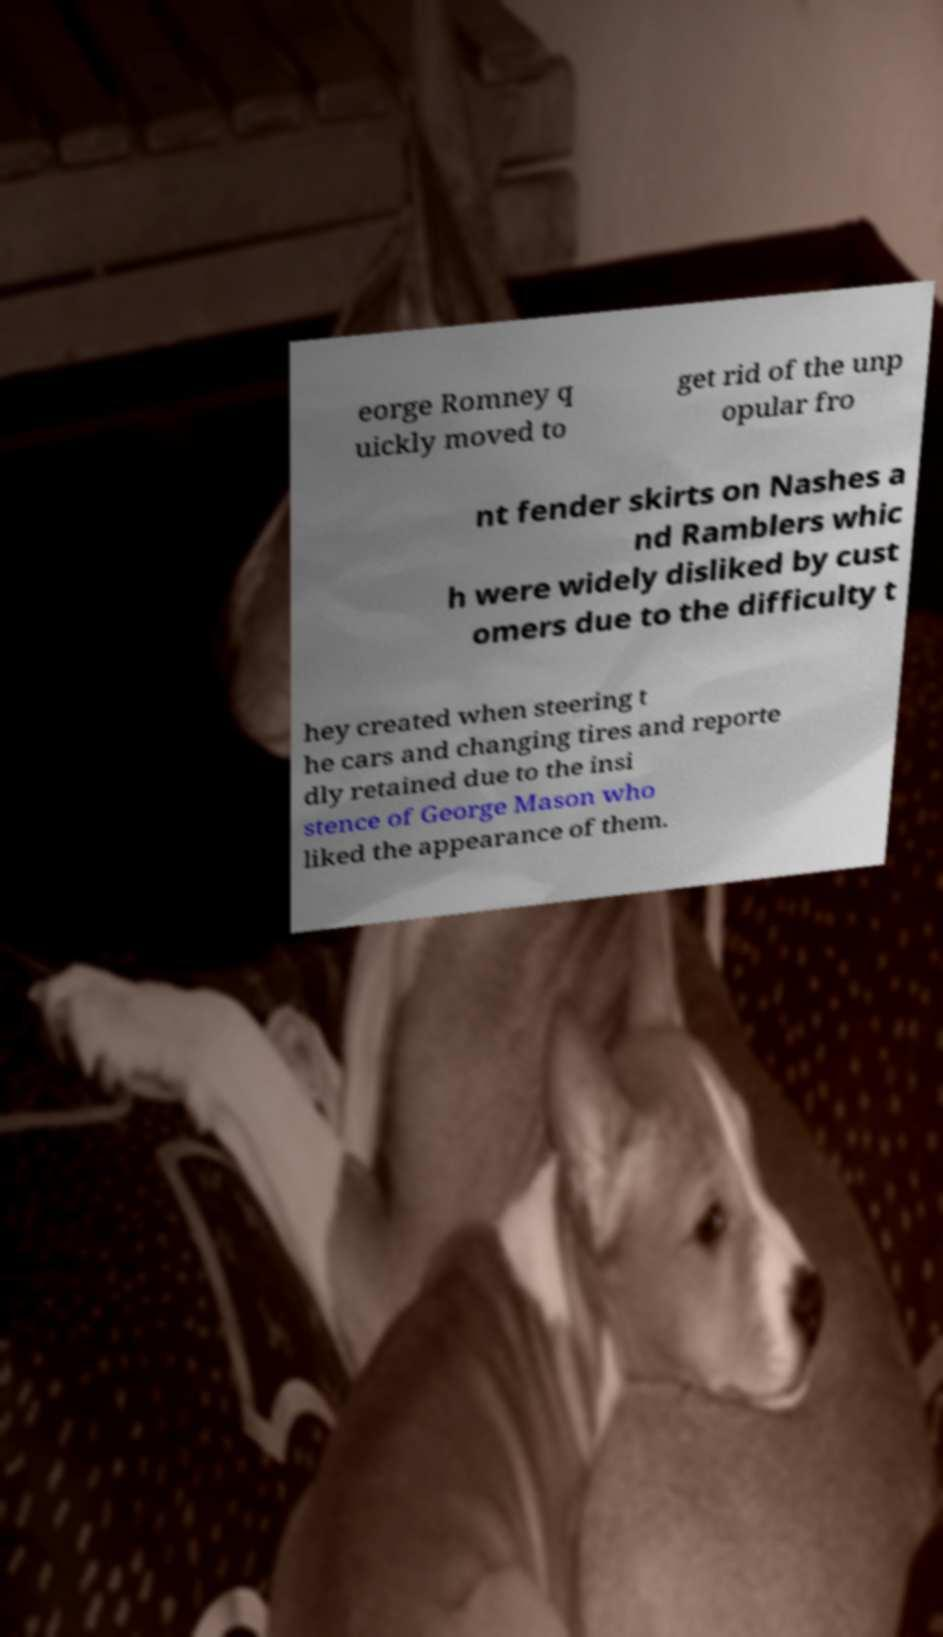Please identify and transcribe the text found in this image. eorge Romney q uickly moved to get rid of the unp opular fro nt fender skirts on Nashes a nd Ramblers whic h were widely disliked by cust omers due to the difficulty t hey created when steering t he cars and changing tires and reporte dly retained due to the insi stence of George Mason who liked the appearance of them. 